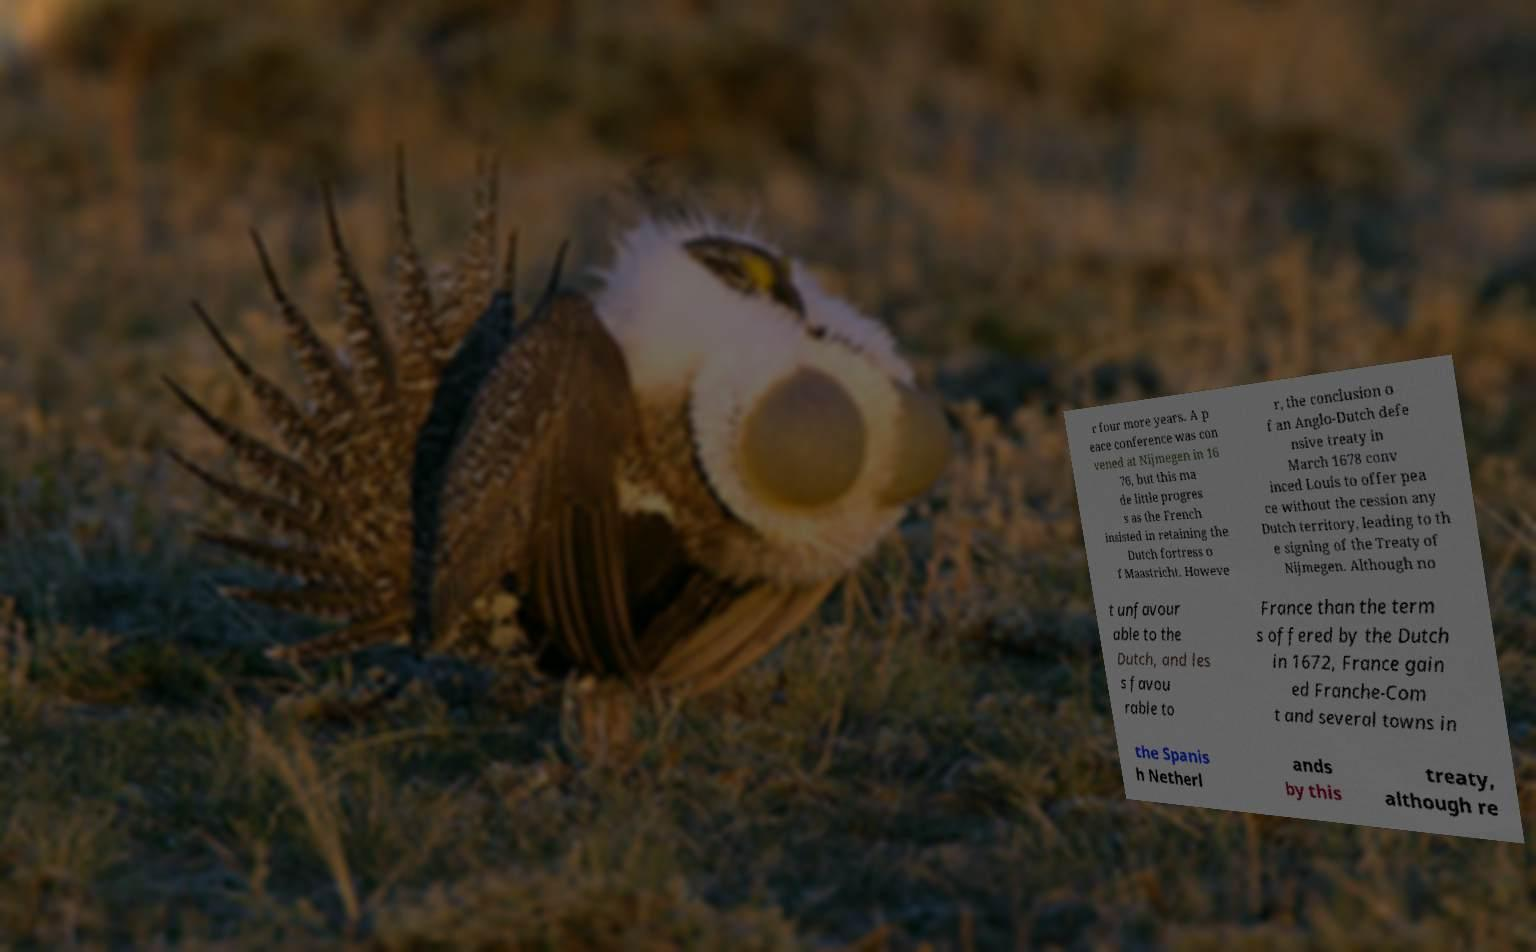For documentation purposes, I need the text within this image transcribed. Could you provide that? r four more years. A p eace conference was con vened at Nijmegen in 16 76, but this ma de little progres s as the French insisted in retaining the Dutch fortress o f Maastricht. Howeve r, the conclusion o f an Anglo-Dutch defe nsive treaty in March 1678 conv inced Louis to offer pea ce without the cession any Dutch territory, leading to th e signing of the Treaty of Nijmegen. Although no t unfavour able to the Dutch, and les s favou rable to France than the term s offered by the Dutch in 1672, France gain ed Franche-Com t and several towns in the Spanis h Netherl ands by this treaty, although re 